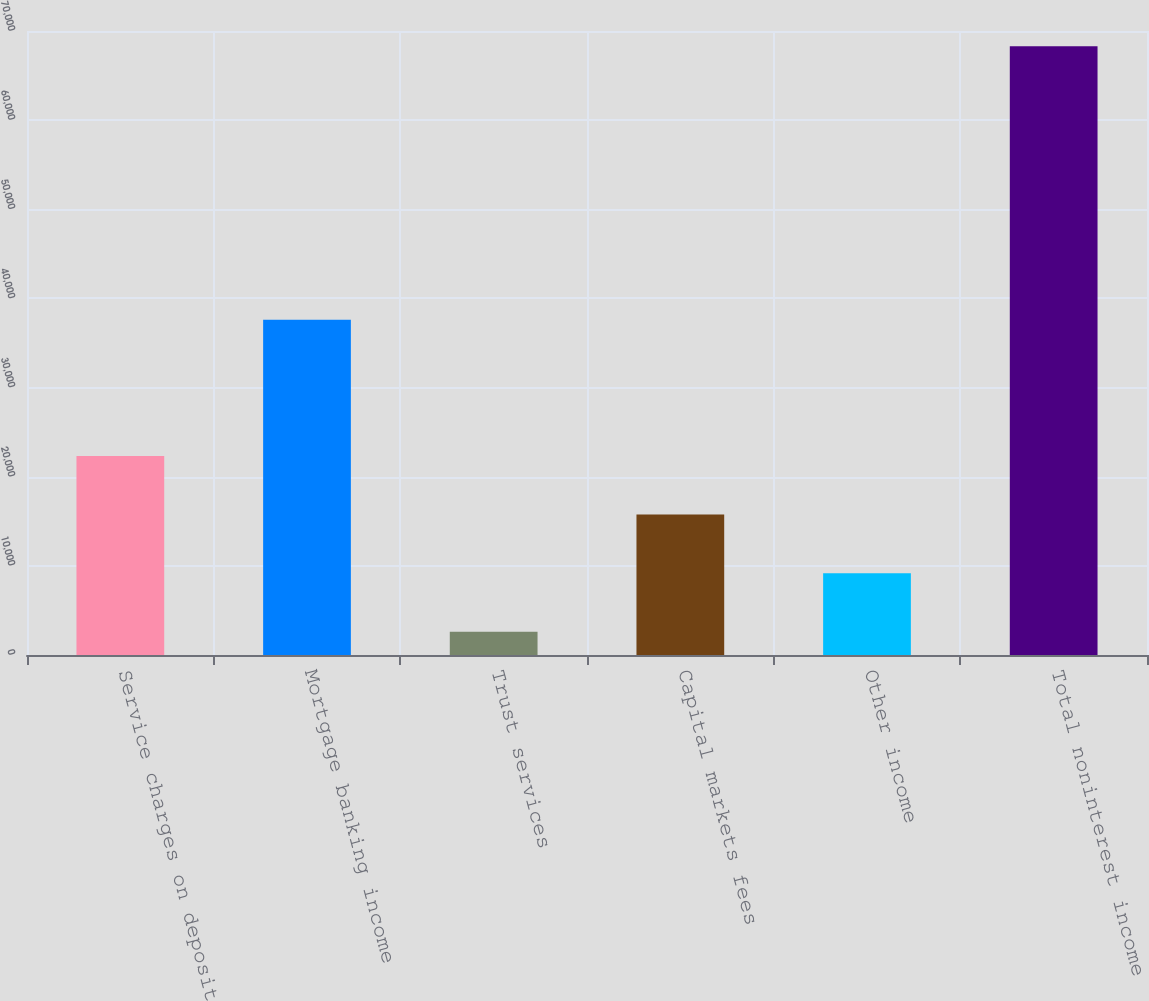<chart> <loc_0><loc_0><loc_500><loc_500><bar_chart><fcel>Service charges on deposit<fcel>Mortgage banking income<fcel>Trust services<fcel>Capital markets fees<fcel>Other income<fcel>Total noninterest income<nl><fcel>22318.8<fcel>37613<fcel>2613<fcel>15750.2<fcel>9181.6<fcel>68299<nl></chart> 